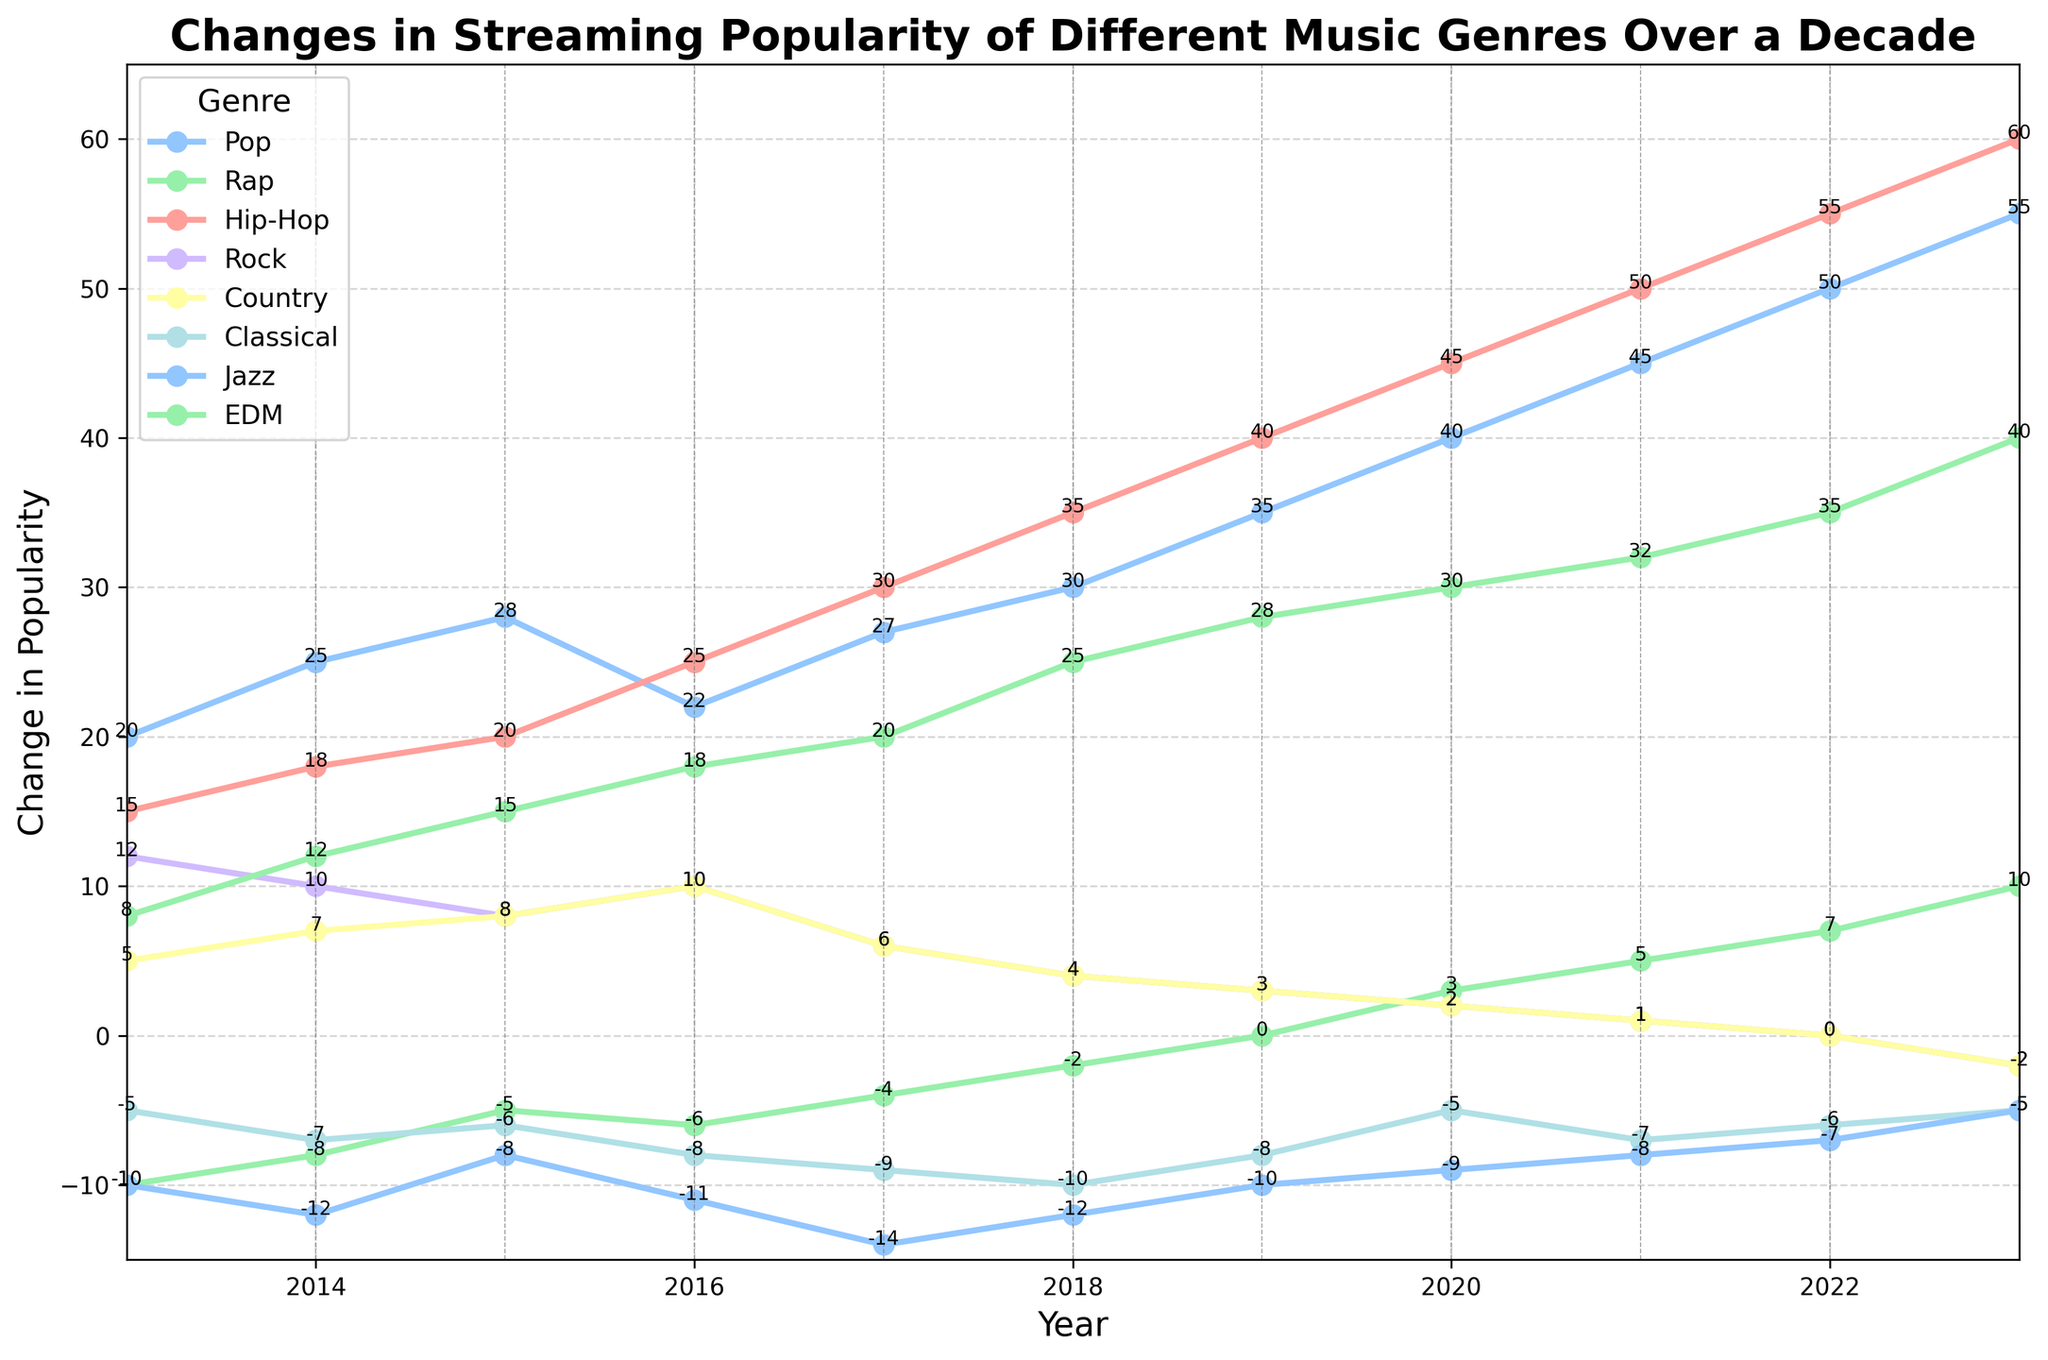Which genre experienced the most overall increase in popularity from 2013 to 2023? By looking at the final and initial values for each genre, we can subtract the 2013 value from the 2023 value. The genre with the highest difference is the one with the most increase. Pop: 55-20=35, Rap: 10-(-10)=20, Hip-Hop: 60-15=45, Rock: -2-12=-14, Country: -2-5=-7, Classical: -5-(-5)=0, Jazz: -5-(-10)=5, EDM: 40-8=32. Hip-Hop has the highest increase.
Answer: Hip-Hop Which two genres had the least change in popularity over the decade? We can compare the absolute differences in popularity for each genre from 2013 to 2023: Pop: 35, Rap: 20, Hip-Hop: 45, Rock: 14, Country: 7, Classical: 0, Jazz: 5, EDM: 32. The two genres with the smallest differences are Classical (0) and Jazz (5).
Answer: Classical and Jazz Which year did EDM first surpass 20 in popularity? By examining the values in the EDM column annually, we find that EDM first reaches above 20 in 2018 (value = 25).
Answer: 2018 Which genre had a negative popularity change in 2023? By looking at the values for the year 2023, we identify negative values in the columns for Rock (-2) and Country (-2).
Answer: Rock and Country In which year did Pop and Hip-Hop have the same change in popularity? By scanning through the values for each year, we find that in 2015, the Pop and Hip-Hop genres have the same change in popularity (both at 20).
Answer: 2015 What was the trend in popularity change for the Classical genre from 2013 to 2023? By examining the values annually: -5, -7, -6, -8, -9, -10, -8, -5, -7, -6, -5, we observe a fluctuating trend generally remaining negative, peaking at -5 in 2013 and 2023.
Answer: Fluctuating but consistently negative For which genre did negative values become positive by 2023? By checking from 2013 to 2023, we see that Rap had a negative value in 2013 (-10) and a positive value in 2023 (10).
Answer: Rap By how much did the popularity of Jazz increase from 2018 to 2023? From the Jazz column, we find the values in 2018 and 2023 are -12 and -5 respectively. Thus, the increase is -5 - (-12) = 7.
Answer: 7 